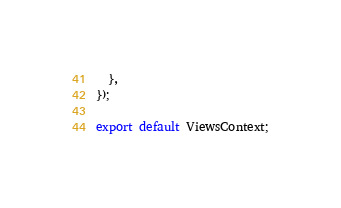Convert code to text. <code><loc_0><loc_0><loc_500><loc_500><_TypeScript_>  },
});

export default ViewsContext;
</code> 